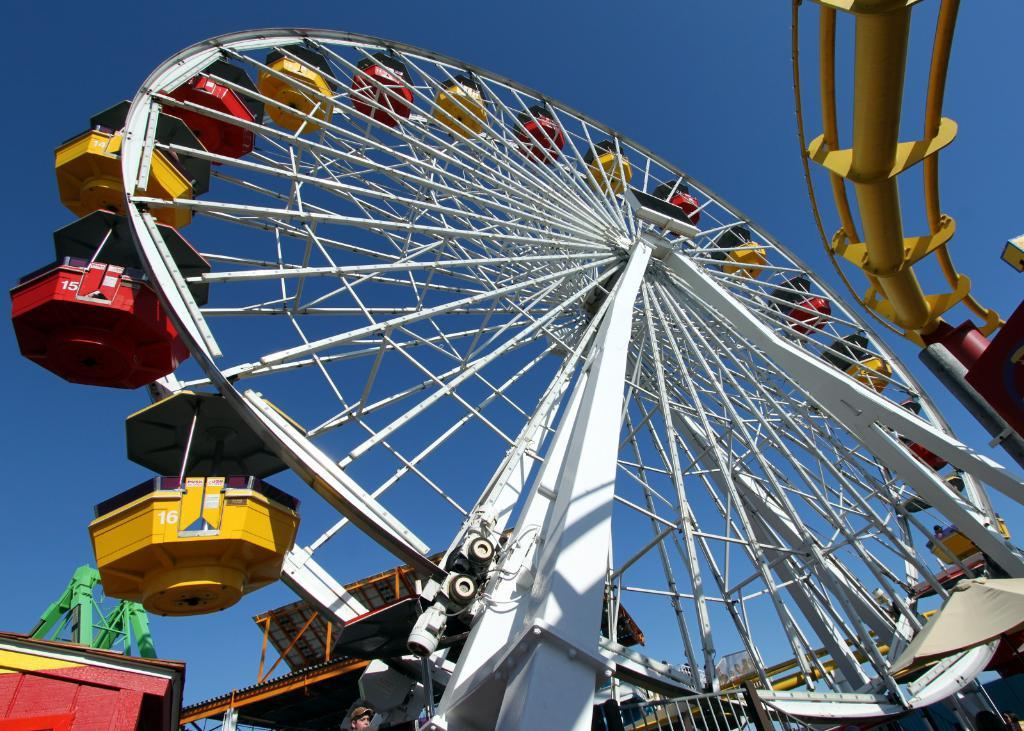What is the main subject in the picture? There is a giant wheel in the picture. What can be seen in the background of the picture? There appears to be a house in the background of the picture. Can you describe the human in the picture? There is a human standing in the picture. Are there any other people present in the image? Yes, there are other riders on the side of the giant wheel. What is the color of the sky in the picture? The sky is blue in the picture. Where is the honey stored in the picture? There is no honey present in the image. What type of lock is used to secure the giant wheel in the picture? There is no lock visible in the image, and the giant wheel does not appear to be secured by any lock. 